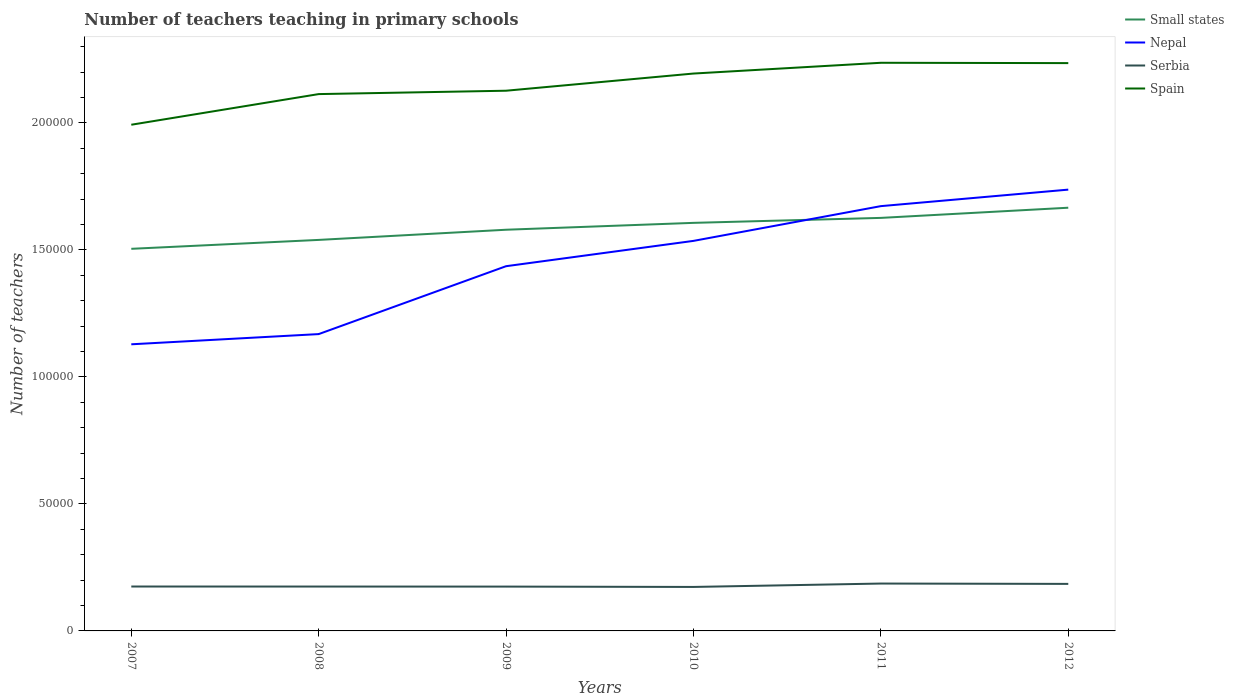Does the line corresponding to Nepal intersect with the line corresponding to Spain?
Offer a very short reply. No. Is the number of lines equal to the number of legend labels?
Ensure brevity in your answer.  Yes. Across all years, what is the maximum number of teachers teaching in primary schools in Serbia?
Provide a short and direct response. 1.73e+04. In which year was the number of teachers teaching in primary schools in Serbia maximum?
Your answer should be very brief. 2010. What is the total number of teachers teaching in primary schools in Spain in the graph?
Make the answer very short. -1.10e+04. What is the difference between the highest and the second highest number of teachers teaching in primary schools in Spain?
Make the answer very short. 2.44e+04. What is the difference between the highest and the lowest number of teachers teaching in primary schools in Spain?
Provide a short and direct response. 3. Is the number of teachers teaching in primary schools in Small states strictly greater than the number of teachers teaching in primary schools in Serbia over the years?
Your answer should be compact. No. How many years are there in the graph?
Offer a very short reply. 6. Are the values on the major ticks of Y-axis written in scientific E-notation?
Offer a terse response. No. Does the graph contain grids?
Offer a very short reply. No. Where does the legend appear in the graph?
Your answer should be very brief. Top right. How are the legend labels stacked?
Make the answer very short. Vertical. What is the title of the graph?
Your answer should be compact. Number of teachers teaching in primary schools. What is the label or title of the X-axis?
Ensure brevity in your answer.  Years. What is the label or title of the Y-axis?
Your answer should be compact. Number of teachers. What is the Number of teachers of Small states in 2007?
Ensure brevity in your answer.  1.50e+05. What is the Number of teachers in Nepal in 2007?
Offer a terse response. 1.13e+05. What is the Number of teachers of Serbia in 2007?
Give a very brief answer. 1.75e+04. What is the Number of teachers in Spain in 2007?
Ensure brevity in your answer.  1.99e+05. What is the Number of teachers of Small states in 2008?
Give a very brief answer. 1.54e+05. What is the Number of teachers in Nepal in 2008?
Ensure brevity in your answer.  1.17e+05. What is the Number of teachers of Serbia in 2008?
Make the answer very short. 1.75e+04. What is the Number of teachers of Spain in 2008?
Keep it short and to the point. 2.11e+05. What is the Number of teachers of Small states in 2009?
Make the answer very short. 1.58e+05. What is the Number of teachers of Nepal in 2009?
Provide a succinct answer. 1.44e+05. What is the Number of teachers of Serbia in 2009?
Your answer should be very brief. 1.74e+04. What is the Number of teachers in Spain in 2009?
Keep it short and to the point. 2.13e+05. What is the Number of teachers of Small states in 2010?
Keep it short and to the point. 1.61e+05. What is the Number of teachers of Nepal in 2010?
Your answer should be very brief. 1.54e+05. What is the Number of teachers in Serbia in 2010?
Provide a short and direct response. 1.73e+04. What is the Number of teachers of Spain in 2010?
Provide a short and direct response. 2.19e+05. What is the Number of teachers of Small states in 2011?
Provide a succinct answer. 1.63e+05. What is the Number of teachers of Nepal in 2011?
Offer a very short reply. 1.67e+05. What is the Number of teachers in Serbia in 2011?
Provide a succinct answer. 1.86e+04. What is the Number of teachers in Spain in 2011?
Your answer should be very brief. 2.24e+05. What is the Number of teachers in Small states in 2012?
Ensure brevity in your answer.  1.67e+05. What is the Number of teachers in Nepal in 2012?
Your response must be concise. 1.74e+05. What is the Number of teachers of Serbia in 2012?
Give a very brief answer. 1.85e+04. What is the Number of teachers of Spain in 2012?
Keep it short and to the point. 2.24e+05. Across all years, what is the maximum Number of teachers in Small states?
Provide a short and direct response. 1.67e+05. Across all years, what is the maximum Number of teachers in Nepal?
Offer a terse response. 1.74e+05. Across all years, what is the maximum Number of teachers in Serbia?
Make the answer very short. 1.86e+04. Across all years, what is the maximum Number of teachers of Spain?
Ensure brevity in your answer.  2.24e+05. Across all years, what is the minimum Number of teachers in Small states?
Your response must be concise. 1.50e+05. Across all years, what is the minimum Number of teachers in Nepal?
Your response must be concise. 1.13e+05. Across all years, what is the minimum Number of teachers of Serbia?
Give a very brief answer. 1.73e+04. Across all years, what is the minimum Number of teachers of Spain?
Keep it short and to the point. 1.99e+05. What is the total Number of teachers of Small states in the graph?
Give a very brief answer. 9.52e+05. What is the total Number of teachers of Nepal in the graph?
Provide a short and direct response. 8.68e+05. What is the total Number of teachers of Serbia in the graph?
Your answer should be compact. 1.07e+05. What is the total Number of teachers in Spain in the graph?
Keep it short and to the point. 1.29e+06. What is the difference between the Number of teachers of Small states in 2007 and that in 2008?
Make the answer very short. -3505.31. What is the difference between the Number of teachers in Nepal in 2007 and that in 2008?
Make the answer very short. -4019. What is the difference between the Number of teachers in Spain in 2007 and that in 2008?
Give a very brief answer. -1.21e+04. What is the difference between the Number of teachers of Small states in 2007 and that in 2009?
Provide a succinct answer. -7508.78. What is the difference between the Number of teachers of Nepal in 2007 and that in 2009?
Offer a terse response. -3.07e+04. What is the difference between the Number of teachers in Spain in 2007 and that in 2009?
Provide a succinct answer. -1.34e+04. What is the difference between the Number of teachers of Small states in 2007 and that in 2010?
Your answer should be compact. -1.02e+04. What is the difference between the Number of teachers of Nepal in 2007 and that in 2010?
Keep it short and to the point. -4.07e+04. What is the difference between the Number of teachers in Serbia in 2007 and that in 2010?
Your response must be concise. 163. What is the difference between the Number of teachers in Spain in 2007 and that in 2010?
Your answer should be compact. -2.02e+04. What is the difference between the Number of teachers in Small states in 2007 and that in 2011?
Your answer should be compact. -1.22e+04. What is the difference between the Number of teachers of Nepal in 2007 and that in 2011?
Your answer should be very brief. -5.44e+04. What is the difference between the Number of teachers of Serbia in 2007 and that in 2011?
Keep it short and to the point. -1171. What is the difference between the Number of teachers in Spain in 2007 and that in 2011?
Your answer should be compact. -2.44e+04. What is the difference between the Number of teachers in Small states in 2007 and that in 2012?
Offer a terse response. -1.62e+04. What is the difference between the Number of teachers in Nepal in 2007 and that in 2012?
Offer a very short reply. -6.09e+04. What is the difference between the Number of teachers in Serbia in 2007 and that in 2012?
Offer a terse response. -1034. What is the difference between the Number of teachers in Spain in 2007 and that in 2012?
Keep it short and to the point. -2.43e+04. What is the difference between the Number of teachers of Small states in 2008 and that in 2009?
Your response must be concise. -4003.47. What is the difference between the Number of teachers in Nepal in 2008 and that in 2009?
Your answer should be very brief. -2.67e+04. What is the difference between the Number of teachers of Serbia in 2008 and that in 2009?
Ensure brevity in your answer.  20. What is the difference between the Number of teachers in Spain in 2008 and that in 2009?
Provide a short and direct response. -1328. What is the difference between the Number of teachers in Small states in 2008 and that in 2010?
Your answer should be very brief. -6708.92. What is the difference between the Number of teachers of Nepal in 2008 and that in 2010?
Give a very brief answer. -3.67e+04. What is the difference between the Number of teachers in Serbia in 2008 and that in 2010?
Ensure brevity in your answer.  155. What is the difference between the Number of teachers of Spain in 2008 and that in 2010?
Offer a terse response. -8089. What is the difference between the Number of teachers of Small states in 2008 and that in 2011?
Make the answer very short. -8664.94. What is the difference between the Number of teachers in Nepal in 2008 and that in 2011?
Give a very brief answer. -5.04e+04. What is the difference between the Number of teachers of Serbia in 2008 and that in 2011?
Make the answer very short. -1179. What is the difference between the Number of teachers of Spain in 2008 and that in 2011?
Ensure brevity in your answer.  -1.23e+04. What is the difference between the Number of teachers in Small states in 2008 and that in 2012?
Your response must be concise. -1.27e+04. What is the difference between the Number of teachers in Nepal in 2008 and that in 2012?
Ensure brevity in your answer.  -5.69e+04. What is the difference between the Number of teachers in Serbia in 2008 and that in 2012?
Offer a terse response. -1042. What is the difference between the Number of teachers of Spain in 2008 and that in 2012?
Provide a short and direct response. -1.22e+04. What is the difference between the Number of teachers of Small states in 2009 and that in 2010?
Keep it short and to the point. -2705.45. What is the difference between the Number of teachers of Nepal in 2009 and that in 2010?
Ensure brevity in your answer.  -9962. What is the difference between the Number of teachers in Serbia in 2009 and that in 2010?
Provide a short and direct response. 135. What is the difference between the Number of teachers of Spain in 2009 and that in 2010?
Offer a terse response. -6761. What is the difference between the Number of teachers of Small states in 2009 and that in 2011?
Offer a very short reply. -4661.47. What is the difference between the Number of teachers of Nepal in 2009 and that in 2011?
Provide a short and direct response. -2.36e+04. What is the difference between the Number of teachers in Serbia in 2009 and that in 2011?
Your answer should be compact. -1199. What is the difference between the Number of teachers in Spain in 2009 and that in 2011?
Give a very brief answer. -1.10e+04. What is the difference between the Number of teachers of Small states in 2009 and that in 2012?
Provide a short and direct response. -8663.89. What is the difference between the Number of teachers of Nepal in 2009 and that in 2012?
Provide a succinct answer. -3.01e+04. What is the difference between the Number of teachers of Serbia in 2009 and that in 2012?
Offer a very short reply. -1062. What is the difference between the Number of teachers in Spain in 2009 and that in 2012?
Provide a succinct answer. -1.09e+04. What is the difference between the Number of teachers in Small states in 2010 and that in 2011?
Offer a very short reply. -1956.02. What is the difference between the Number of teachers of Nepal in 2010 and that in 2011?
Keep it short and to the point. -1.37e+04. What is the difference between the Number of teachers in Serbia in 2010 and that in 2011?
Provide a short and direct response. -1334. What is the difference between the Number of teachers of Spain in 2010 and that in 2011?
Provide a short and direct response. -4235. What is the difference between the Number of teachers of Small states in 2010 and that in 2012?
Offer a very short reply. -5958.44. What is the difference between the Number of teachers of Nepal in 2010 and that in 2012?
Ensure brevity in your answer.  -2.02e+04. What is the difference between the Number of teachers of Serbia in 2010 and that in 2012?
Your answer should be compact. -1197. What is the difference between the Number of teachers of Spain in 2010 and that in 2012?
Offer a terse response. -4108. What is the difference between the Number of teachers in Small states in 2011 and that in 2012?
Ensure brevity in your answer.  -4002.42. What is the difference between the Number of teachers of Nepal in 2011 and that in 2012?
Your answer should be compact. -6498. What is the difference between the Number of teachers in Serbia in 2011 and that in 2012?
Offer a terse response. 137. What is the difference between the Number of teachers of Spain in 2011 and that in 2012?
Your answer should be very brief. 127. What is the difference between the Number of teachers of Small states in 2007 and the Number of teachers of Nepal in 2008?
Make the answer very short. 3.36e+04. What is the difference between the Number of teachers of Small states in 2007 and the Number of teachers of Serbia in 2008?
Your response must be concise. 1.33e+05. What is the difference between the Number of teachers of Small states in 2007 and the Number of teachers of Spain in 2008?
Your response must be concise. -6.09e+04. What is the difference between the Number of teachers in Nepal in 2007 and the Number of teachers in Serbia in 2008?
Keep it short and to the point. 9.54e+04. What is the difference between the Number of teachers in Nepal in 2007 and the Number of teachers in Spain in 2008?
Provide a short and direct response. -9.85e+04. What is the difference between the Number of teachers of Serbia in 2007 and the Number of teachers of Spain in 2008?
Your response must be concise. -1.94e+05. What is the difference between the Number of teachers of Small states in 2007 and the Number of teachers of Nepal in 2009?
Your answer should be very brief. 6842.36. What is the difference between the Number of teachers of Small states in 2007 and the Number of teachers of Serbia in 2009?
Give a very brief answer. 1.33e+05. What is the difference between the Number of teachers of Small states in 2007 and the Number of teachers of Spain in 2009?
Provide a succinct answer. -6.22e+04. What is the difference between the Number of teachers in Nepal in 2007 and the Number of teachers in Serbia in 2009?
Your answer should be compact. 9.54e+04. What is the difference between the Number of teachers in Nepal in 2007 and the Number of teachers in Spain in 2009?
Make the answer very short. -9.98e+04. What is the difference between the Number of teachers in Serbia in 2007 and the Number of teachers in Spain in 2009?
Ensure brevity in your answer.  -1.95e+05. What is the difference between the Number of teachers in Small states in 2007 and the Number of teachers in Nepal in 2010?
Provide a succinct answer. -3119.64. What is the difference between the Number of teachers of Small states in 2007 and the Number of teachers of Serbia in 2010?
Make the answer very short. 1.33e+05. What is the difference between the Number of teachers in Small states in 2007 and the Number of teachers in Spain in 2010?
Provide a short and direct response. -6.90e+04. What is the difference between the Number of teachers of Nepal in 2007 and the Number of teachers of Serbia in 2010?
Make the answer very short. 9.55e+04. What is the difference between the Number of teachers of Nepal in 2007 and the Number of teachers of Spain in 2010?
Give a very brief answer. -1.07e+05. What is the difference between the Number of teachers of Serbia in 2007 and the Number of teachers of Spain in 2010?
Offer a terse response. -2.02e+05. What is the difference between the Number of teachers in Small states in 2007 and the Number of teachers in Nepal in 2011?
Provide a succinct answer. -1.68e+04. What is the difference between the Number of teachers in Small states in 2007 and the Number of teachers in Serbia in 2011?
Provide a succinct answer. 1.32e+05. What is the difference between the Number of teachers of Small states in 2007 and the Number of teachers of Spain in 2011?
Your response must be concise. -7.32e+04. What is the difference between the Number of teachers of Nepal in 2007 and the Number of teachers of Serbia in 2011?
Offer a very short reply. 9.42e+04. What is the difference between the Number of teachers of Nepal in 2007 and the Number of teachers of Spain in 2011?
Your response must be concise. -1.11e+05. What is the difference between the Number of teachers in Serbia in 2007 and the Number of teachers in Spain in 2011?
Provide a short and direct response. -2.06e+05. What is the difference between the Number of teachers of Small states in 2007 and the Number of teachers of Nepal in 2012?
Give a very brief answer. -2.33e+04. What is the difference between the Number of teachers in Small states in 2007 and the Number of teachers in Serbia in 2012?
Your answer should be compact. 1.32e+05. What is the difference between the Number of teachers in Small states in 2007 and the Number of teachers in Spain in 2012?
Offer a very short reply. -7.31e+04. What is the difference between the Number of teachers of Nepal in 2007 and the Number of teachers of Serbia in 2012?
Offer a terse response. 9.43e+04. What is the difference between the Number of teachers in Nepal in 2007 and the Number of teachers in Spain in 2012?
Provide a succinct answer. -1.11e+05. What is the difference between the Number of teachers of Serbia in 2007 and the Number of teachers of Spain in 2012?
Provide a short and direct response. -2.06e+05. What is the difference between the Number of teachers in Small states in 2008 and the Number of teachers in Nepal in 2009?
Ensure brevity in your answer.  1.03e+04. What is the difference between the Number of teachers of Small states in 2008 and the Number of teachers of Serbia in 2009?
Provide a succinct answer. 1.36e+05. What is the difference between the Number of teachers of Small states in 2008 and the Number of teachers of Spain in 2009?
Offer a very short reply. -5.87e+04. What is the difference between the Number of teachers of Nepal in 2008 and the Number of teachers of Serbia in 2009?
Provide a succinct answer. 9.94e+04. What is the difference between the Number of teachers of Nepal in 2008 and the Number of teachers of Spain in 2009?
Your answer should be very brief. -9.58e+04. What is the difference between the Number of teachers in Serbia in 2008 and the Number of teachers in Spain in 2009?
Offer a very short reply. -1.95e+05. What is the difference between the Number of teachers of Small states in 2008 and the Number of teachers of Nepal in 2010?
Keep it short and to the point. 385.67. What is the difference between the Number of teachers of Small states in 2008 and the Number of teachers of Serbia in 2010?
Make the answer very short. 1.37e+05. What is the difference between the Number of teachers in Small states in 2008 and the Number of teachers in Spain in 2010?
Offer a very short reply. -6.55e+04. What is the difference between the Number of teachers of Nepal in 2008 and the Number of teachers of Serbia in 2010?
Your answer should be very brief. 9.95e+04. What is the difference between the Number of teachers in Nepal in 2008 and the Number of teachers in Spain in 2010?
Keep it short and to the point. -1.03e+05. What is the difference between the Number of teachers of Serbia in 2008 and the Number of teachers of Spain in 2010?
Keep it short and to the point. -2.02e+05. What is the difference between the Number of teachers in Small states in 2008 and the Number of teachers in Nepal in 2011?
Provide a short and direct response. -1.33e+04. What is the difference between the Number of teachers of Small states in 2008 and the Number of teachers of Serbia in 2011?
Your answer should be very brief. 1.35e+05. What is the difference between the Number of teachers of Small states in 2008 and the Number of teachers of Spain in 2011?
Provide a succinct answer. -6.97e+04. What is the difference between the Number of teachers of Nepal in 2008 and the Number of teachers of Serbia in 2011?
Provide a succinct answer. 9.82e+04. What is the difference between the Number of teachers in Nepal in 2008 and the Number of teachers in Spain in 2011?
Offer a very short reply. -1.07e+05. What is the difference between the Number of teachers in Serbia in 2008 and the Number of teachers in Spain in 2011?
Offer a very short reply. -2.06e+05. What is the difference between the Number of teachers in Small states in 2008 and the Number of teachers in Nepal in 2012?
Offer a very short reply. -1.98e+04. What is the difference between the Number of teachers in Small states in 2008 and the Number of teachers in Serbia in 2012?
Provide a succinct answer. 1.35e+05. What is the difference between the Number of teachers in Small states in 2008 and the Number of teachers in Spain in 2012?
Keep it short and to the point. -6.96e+04. What is the difference between the Number of teachers of Nepal in 2008 and the Number of teachers of Serbia in 2012?
Give a very brief answer. 9.83e+04. What is the difference between the Number of teachers in Nepal in 2008 and the Number of teachers in Spain in 2012?
Provide a succinct answer. -1.07e+05. What is the difference between the Number of teachers of Serbia in 2008 and the Number of teachers of Spain in 2012?
Give a very brief answer. -2.06e+05. What is the difference between the Number of teachers in Small states in 2009 and the Number of teachers in Nepal in 2010?
Offer a very short reply. 4389.14. What is the difference between the Number of teachers of Small states in 2009 and the Number of teachers of Serbia in 2010?
Your response must be concise. 1.41e+05. What is the difference between the Number of teachers of Small states in 2009 and the Number of teachers of Spain in 2010?
Offer a terse response. -6.15e+04. What is the difference between the Number of teachers in Nepal in 2009 and the Number of teachers in Serbia in 2010?
Offer a terse response. 1.26e+05. What is the difference between the Number of teachers of Nepal in 2009 and the Number of teachers of Spain in 2010?
Your answer should be compact. -7.58e+04. What is the difference between the Number of teachers in Serbia in 2009 and the Number of teachers in Spain in 2010?
Provide a short and direct response. -2.02e+05. What is the difference between the Number of teachers in Small states in 2009 and the Number of teachers in Nepal in 2011?
Give a very brief answer. -9290.86. What is the difference between the Number of teachers in Small states in 2009 and the Number of teachers in Serbia in 2011?
Offer a terse response. 1.39e+05. What is the difference between the Number of teachers of Small states in 2009 and the Number of teachers of Spain in 2011?
Offer a very short reply. -6.57e+04. What is the difference between the Number of teachers of Nepal in 2009 and the Number of teachers of Serbia in 2011?
Keep it short and to the point. 1.25e+05. What is the difference between the Number of teachers of Nepal in 2009 and the Number of teachers of Spain in 2011?
Your answer should be compact. -8.01e+04. What is the difference between the Number of teachers of Serbia in 2009 and the Number of teachers of Spain in 2011?
Ensure brevity in your answer.  -2.06e+05. What is the difference between the Number of teachers of Small states in 2009 and the Number of teachers of Nepal in 2012?
Your answer should be compact. -1.58e+04. What is the difference between the Number of teachers in Small states in 2009 and the Number of teachers in Serbia in 2012?
Offer a terse response. 1.39e+05. What is the difference between the Number of teachers in Small states in 2009 and the Number of teachers in Spain in 2012?
Your answer should be compact. -6.56e+04. What is the difference between the Number of teachers in Nepal in 2009 and the Number of teachers in Serbia in 2012?
Provide a short and direct response. 1.25e+05. What is the difference between the Number of teachers in Nepal in 2009 and the Number of teachers in Spain in 2012?
Keep it short and to the point. -7.99e+04. What is the difference between the Number of teachers of Serbia in 2009 and the Number of teachers of Spain in 2012?
Offer a terse response. -2.06e+05. What is the difference between the Number of teachers in Small states in 2010 and the Number of teachers in Nepal in 2011?
Ensure brevity in your answer.  -6585.41. What is the difference between the Number of teachers of Small states in 2010 and the Number of teachers of Serbia in 2011?
Offer a very short reply. 1.42e+05. What is the difference between the Number of teachers in Small states in 2010 and the Number of teachers in Spain in 2011?
Provide a succinct answer. -6.30e+04. What is the difference between the Number of teachers in Nepal in 2010 and the Number of teachers in Serbia in 2011?
Offer a very short reply. 1.35e+05. What is the difference between the Number of teachers in Nepal in 2010 and the Number of teachers in Spain in 2011?
Your answer should be very brief. -7.01e+04. What is the difference between the Number of teachers in Serbia in 2010 and the Number of teachers in Spain in 2011?
Your answer should be very brief. -2.06e+05. What is the difference between the Number of teachers in Small states in 2010 and the Number of teachers in Nepal in 2012?
Offer a very short reply. -1.31e+04. What is the difference between the Number of teachers in Small states in 2010 and the Number of teachers in Serbia in 2012?
Give a very brief answer. 1.42e+05. What is the difference between the Number of teachers of Small states in 2010 and the Number of teachers of Spain in 2012?
Give a very brief answer. -6.29e+04. What is the difference between the Number of teachers in Nepal in 2010 and the Number of teachers in Serbia in 2012?
Offer a terse response. 1.35e+05. What is the difference between the Number of teachers in Nepal in 2010 and the Number of teachers in Spain in 2012?
Provide a succinct answer. -7.00e+04. What is the difference between the Number of teachers in Serbia in 2010 and the Number of teachers in Spain in 2012?
Offer a very short reply. -2.06e+05. What is the difference between the Number of teachers in Small states in 2011 and the Number of teachers in Nepal in 2012?
Make the answer very short. -1.11e+04. What is the difference between the Number of teachers of Small states in 2011 and the Number of teachers of Serbia in 2012?
Your response must be concise. 1.44e+05. What is the difference between the Number of teachers in Small states in 2011 and the Number of teachers in Spain in 2012?
Your answer should be compact. -6.09e+04. What is the difference between the Number of teachers in Nepal in 2011 and the Number of teachers in Serbia in 2012?
Make the answer very short. 1.49e+05. What is the difference between the Number of teachers of Nepal in 2011 and the Number of teachers of Spain in 2012?
Offer a terse response. -5.63e+04. What is the difference between the Number of teachers of Serbia in 2011 and the Number of teachers of Spain in 2012?
Offer a very short reply. -2.05e+05. What is the average Number of teachers of Small states per year?
Provide a short and direct response. 1.59e+05. What is the average Number of teachers of Nepal per year?
Offer a terse response. 1.45e+05. What is the average Number of teachers of Serbia per year?
Your answer should be very brief. 1.78e+04. What is the average Number of teachers of Spain per year?
Your response must be concise. 2.15e+05. In the year 2007, what is the difference between the Number of teachers in Small states and Number of teachers in Nepal?
Provide a short and direct response. 3.76e+04. In the year 2007, what is the difference between the Number of teachers in Small states and Number of teachers in Serbia?
Your answer should be compact. 1.33e+05. In the year 2007, what is the difference between the Number of teachers of Small states and Number of teachers of Spain?
Ensure brevity in your answer.  -4.88e+04. In the year 2007, what is the difference between the Number of teachers in Nepal and Number of teachers in Serbia?
Provide a succinct answer. 9.54e+04. In the year 2007, what is the difference between the Number of teachers of Nepal and Number of teachers of Spain?
Make the answer very short. -8.64e+04. In the year 2007, what is the difference between the Number of teachers of Serbia and Number of teachers of Spain?
Your response must be concise. -1.82e+05. In the year 2008, what is the difference between the Number of teachers of Small states and Number of teachers of Nepal?
Keep it short and to the point. 3.71e+04. In the year 2008, what is the difference between the Number of teachers of Small states and Number of teachers of Serbia?
Offer a very short reply. 1.36e+05. In the year 2008, what is the difference between the Number of teachers in Small states and Number of teachers in Spain?
Provide a succinct answer. -5.74e+04. In the year 2008, what is the difference between the Number of teachers of Nepal and Number of teachers of Serbia?
Keep it short and to the point. 9.94e+04. In the year 2008, what is the difference between the Number of teachers of Nepal and Number of teachers of Spain?
Offer a very short reply. -9.45e+04. In the year 2008, what is the difference between the Number of teachers in Serbia and Number of teachers in Spain?
Your answer should be compact. -1.94e+05. In the year 2009, what is the difference between the Number of teachers of Small states and Number of teachers of Nepal?
Ensure brevity in your answer.  1.44e+04. In the year 2009, what is the difference between the Number of teachers of Small states and Number of teachers of Serbia?
Provide a succinct answer. 1.40e+05. In the year 2009, what is the difference between the Number of teachers in Small states and Number of teachers in Spain?
Offer a terse response. -5.47e+04. In the year 2009, what is the difference between the Number of teachers in Nepal and Number of teachers in Serbia?
Your answer should be compact. 1.26e+05. In the year 2009, what is the difference between the Number of teachers of Nepal and Number of teachers of Spain?
Keep it short and to the point. -6.91e+04. In the year 2009, what is the difference between the Number of teachers of Serbia and Number of teachers of Spain?
Ensure brevity in your answer.  -1.95e+05. In the year 2010, what is the difference between the Number of teachers in Small states and Number of teachers in Nepal?
Provide a short and direct response. 7094.59. In the year 2010, what is the difference between the Number of teachers of Small states and Number of teachers of Serbia?
Provide a succinct answer. 1.43e+05. In the year 2010, what is the difference between the Number of teachers of Small states and Number of teachers of Spain?
Give a very brief answer. -5.88e+04. In the year 2010, what is the difference between the Number of teachers in Nepal and Number of teachers in Serbia?
Offer a very short reply. 1.36e+05. In the year 2010, what is the difference between the Number of teachers in Nepal and Number of teachers in Spain?
Provide a succinct answer. -6.59e+04. In the year 2010, what is the difference between the Number of teachers of Serbia and Number of teachers of Spain?
Your answer should be very brief. -2.02e+05. In the year 2011, what is the difference between the Number of teachers of Small states and Number of teachers of Nepal?
Your response must be concise. -4629.39. In the year 2011, what is the difference between the Number of teachers of Small states and Number of teachers of Serbia?
Give a very brief answer. 1.44e+05. In the year 2011, what is the difference between the Number of teachers in Small states and Number of teachers in Spain?
Provide a succinct answer. -6.11e+04. In the year 2011, what is the difference between the Number of teachers in Nepal and Number of teachers in Serbia?
Give a very brief answer. 1.49e+05. In the year 2011, what is the difference between the Number of teachers of Nepal and Number of teachers of Spain?
Ensure brevity in your answer.  -5.64e+04. In the year 2011, what is the difference between the Number of teachers in Serbia and Number of teachers in Spain?
Offer a very short reply. -2.05e+05. In the year 2012, what is the difference between the Number of teachers in Small states and Number of teachers in Nepal?
Offer a very short reply. -7124.97. In the year 2012, what is the difference between the Number of teachers of Small states and Number of teachers of Serbia?
Ensure brevity in your answer.  1.48e+05. In the year 2012, what is the difference between the Number of teachers in Small states and Number of teachers in Spain?
Offer a very short reply. -5.69e+04. In the year 2012, what is the difference between the Number of teachers in Nepal and Number of teachers in Serbia?
Ensure brevity in your answer.  1.55e+05. In the year 2012, what is the difference between the Number of teachers of Nepal and Number of teachers of Spain?
Your response must be concise. -4.98e+04. In the year 2012, what is the difference between the Number of teachers of Serbia and Number of teachers of Spain?
Your answer should be compact. -2.05e+05. What is the ratio of the Number of teachers of Small states in 2007 to that in 2008?
Ensure brevity in your answer.  0.98. What is the ratio of the Number of teachers of Nepal in 2007 to that in 2008?
Provide a short and direct response. 0.97. What is the ratio of the Number of teachers of Serbia in 2007 to that in 2008?
Keep it short and to the point. 1. What is the ratio of the Number of teachers of Spain in 2007 to that in 2008?
Provide a succinct answer. 0.94. What is the ratio of the Number of teachers of Small states in 2007 to that in 2009?
Make the answer very short. 0.95. What is the ratio of the Number of teachers of Nepal in 2007 to that in 2009?
Keep it short and to the point. 0.79. What is the ratio of the Number of teachers of Serbia in 2007 to that in 2009?
Your response must be concise. 1. What is the ratio of the Number of teachers in Spain in 2007 to that in 2009?
Offer a very short reply. 0.94. What is the ratio of the Number of teachers of Small states in 2007 to that in 2010?
Ensure brevity in your answer.  0.94. What is the ratio of the Number of teachers of Nepal in 2007 to that in 2010?
Keep it short and to the point. 0.73. What is the ratio of the Number of teachers in Serbia in 2007 to that in 2010?
Offer a terse response. 1.01. What is the ratio of the Number of teachers in Spain in 2007 to that in 2010?
Make the answer very short. 0.91. What is the ratio of the Number of teachers of Small states in 2007 to that in 2011?
Offer a very short reply. 0.93. What is the ratio of the Number of teachers of Nepal in 2007 to that in 2011?
Give a very brief answer. 0.67. What is the ratio of the Number of teachers in Serbia in 2007 to that in 2011?
Give a very brief answer. 0.94. What is the ratio of the Number of teachers in Spain in 2007 to that in 2011?
Your response must be concise. 0.89. What is the ratio of the Number of teachers in Small states in 2007 to that in 2012?
Your response must be concise. 0.9. What is the ratio of the Number of teachers in Nepal in 2007 to that in 2012?
Ensure brevity in your answer.  0.65. What is the ratio of the Number of teachers of Serbia in 2007 to that in 2012?
Keep it short and to the point. 0.94. What is the ratio of the Number of teachers in Spain in 2007 to that in 2012?
Your answer should be compact. 0.89. What is the ratio of the Number of teachers of Small states in 2008 to that in 2009?
Provide a short and direct response. 0.97. What is the ratio of the Number of teachers in Nepal in 2008 to that in 2009?
Make the answer very short. 0.81. What is the ratio of the Number of teachers of Serbia in 2008 to that in 2009?
Keep it short and to the point. 1. What is the ratio of the Number of teachers of Small states in 2008 to that in 2010?
Your response must be concise. 0.96. What is the ratio of the Number of teachers in Nepal in 2008 to that in 2010?
Give a very brief answer. 0.76. What is the ratio of the Number of teachers in Serbia in 2008 to that in 2010?
Offer a very short reply. 1.01. What is the ratio of the Number of teachers of Spain in 2008 to that in 2010?
Make the answer very short. 0.96. What is the ratio of the Number of teachers of Small states in 2008 to that in 2011?
Provide a succinct answer. 0.95. What is the ratio of the Number of teachers in Nepal in 2008 to that in 2011?
Provide a succinct answer. 0.7. What is the ratio of the Number of teachers of Serbia in 2008 to that in 2011?
Keep it short and to the point. 0.94. What is the ratio of the Number of teachers in Spain in 2008 to that in 2011?
Provide a succinct answer. 0.94. What is the ratio of the Number of teachers of Small states in 2008 to that in 2012?
Give a very brief answer. 0.92. What is the ratio of the Number of teachers in Nepal in 2008 to that in 2012?
Your answer should be very brief. 0.67. What is the ratio of the Number of teachers of Serbia in 2008 to that in 2012?
Provide a succinct answer. 0.94. What is the ratio of the Number of teachers in Spain in 2008 to that in 2012?
Offer a terse response. 0.95. What is the ratio of the Number of teachers of Small states in 2009 to that in 2010?
Offer a very short reply. 0.98. What is the ratio of the Number of teachers of Nepal in 2009 to that in 2010?
Your response must be concise. 0.94. What is the ratio of the Number of teachers in Serbia in 2009 to that in 2010?
Offer a very short reply. 1.01. What is the ratio of the Number of teachers of Spain in 2009 to that in 2010?
Offer a terse response. 0.97. What is the ratio of the Number of teachers in Small states in 2009 to that in 2011?
Make the answer very short. 0.97. What is the ratio of the Number of teachers in Nepal in 2009 to that in 2011?
Keep it short and to the point. 0.86. What is the ratio of the Number of teachers in Serbia in 2009 to that in 2011?
Offer a terse response. 0.94. What is the ratio of the Number of teachers in Spain in 2009 to that in 2011?
Offer a very short reply. 0.95. What is the ratio of the Number of teachers of Small states in 2009 to that in 2012?
Give a very brief answer. 0.95. What is the ratio of the Number of teachers of Nepal in 2009 to that in 2012?
Provide a succinct answer. 0.83. What is the ratio of the Number of teachers in Serbia in 2009 to that in 2012?
Your answer should be very brief. 0.94. What is the ratio of the Number of teachers in Spain in 2009 to that in 2012?
Keep it short and to the point. 0.95. What is the ratio of the Number of teachers of Nepal in 2010 to that in 2011?
Make the answer very short. 0.92. What is the ratio of the Number of teachers in Serbia in 2010 to that in 2011?
Offer a terse response. 0.93. What is the ratio of the Number of teachers of Spain in 2010 to that in 2011?
Ensure brevity in your answer.  0.98. What is the ratio of the Number of teachers in Small states in 2010 to that in 2012?
Your answer should be compact. 0.96. What is the ratio of the Number of teachers of Nepal in 2010 to that in 2012?
Provide a succinct answer. 0.88. What is the ratio of the Number of teachers of Serbia in 2010 to that in 2012?
Your answer should be very brief. 0.94. What is the ratio of the Number of teachers of Spain in 2010 to that in 2012?
Your answer should be very brief. 0.98. What is the ratio of the Number of teachers in Nepal in 2011 to that in 2012?
Your response must be concise. 0.96. What is the ratio of the Number of teachers of Serbia in 2011 to that in 2012?
Keep it short and to the point. 1.01. What is the difference between the highest and the second highest Number of teachers of Small states?
Your answer should be compact. 4002.42. What is the difference between the highest and the second highest Number of teachers of Nepal?
Make the answer very short. 6498. What is the difference between the highest and the second highest Number of teachers in Serbia?
Give a very brief answer. 137. What is the difference between the highest and the second highest Number of teachers of Spain?
Keep it short and to the point. 127. What is the difference between the highest and the lowest Number of teachers of Small states?
Offer a terse response. 1.62e+04. What is the difference between the highest and the lowest Number of teachers of Nepal?
Make the answer very short. 6.09e+04. What is the difference between the highest and the lowest Number of teachers in Serbia?
Offer a very short reply. 1334. What is the difference between the highest and the lowest Number of teachers of Spain?
Provide a succinct answer. 2.44e+04. 